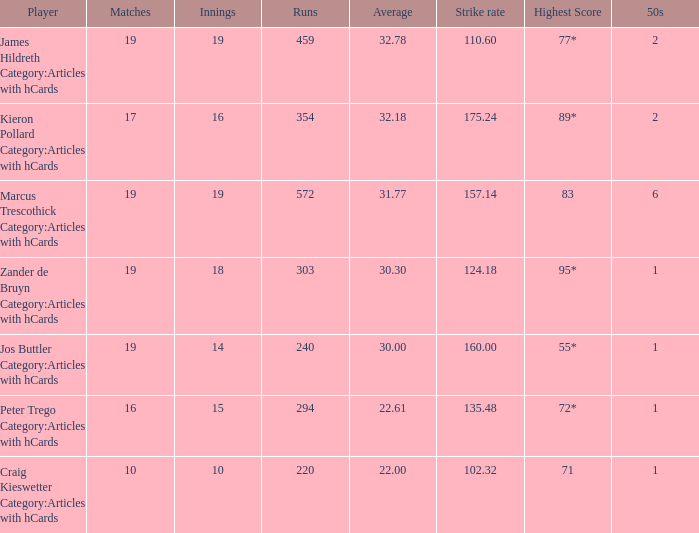What is the highest score for the player with average of 30.00? 55*. 